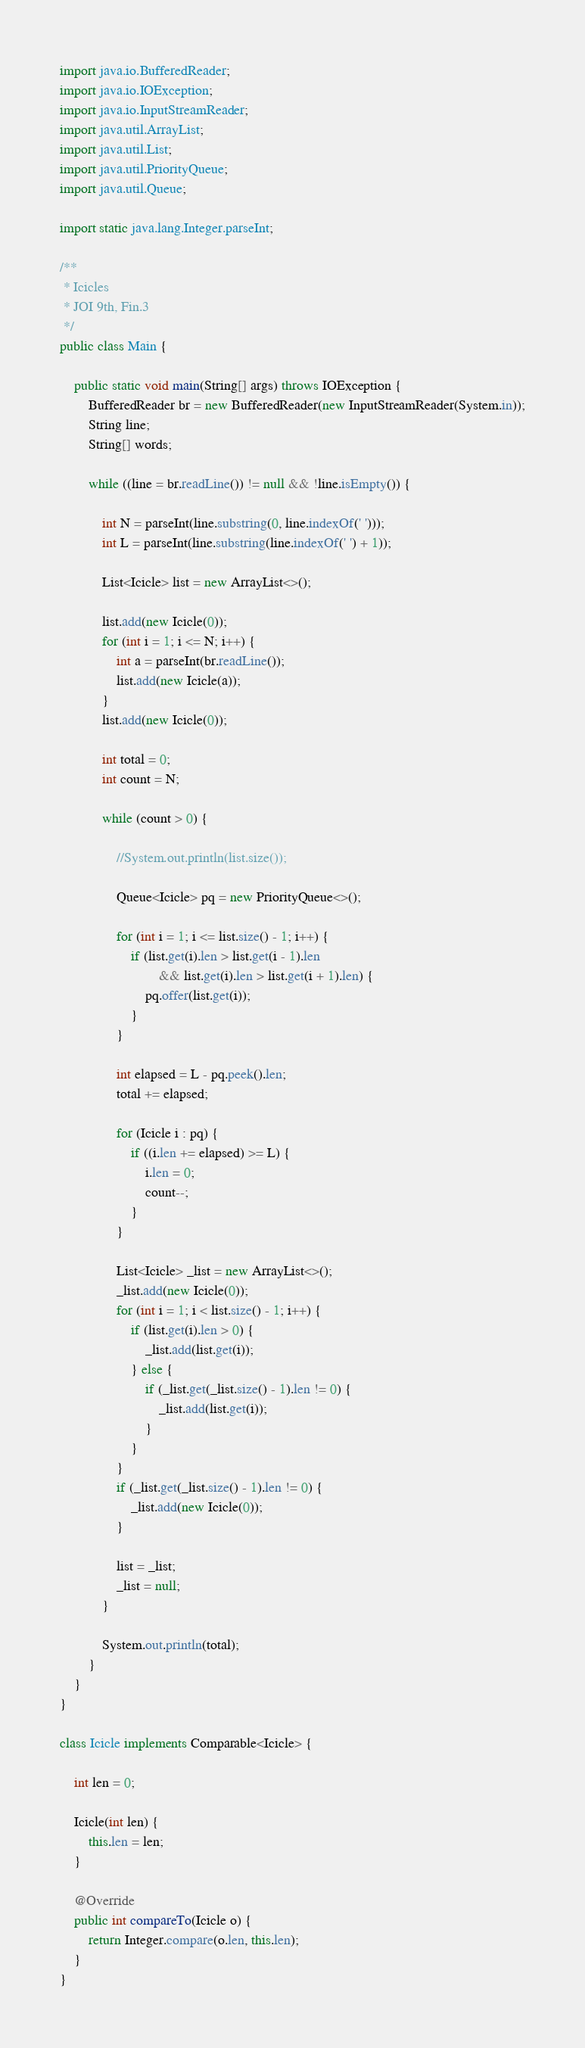Convert code to text. <code><loc_0><loc_0><loc_500><loc_500><_Java_>import java.io.BufferedReader;
import java.io.IOException;
import java.io.InputStreamReader;
import java.util.ArrayList;
import java.util.List;
import java.util.PriorityQueue;
import java.util.Queue;

import static java.lang.Integer.parseInt;

/**
 * Icicles
 * JOI 9th, Fin.3
 */
public class Main {

	public static void main(String[] args) throws IOException {
		BufferedReader br = new BufferedReader(new InputStreamReader(System.in));
		String line;
		String[] words;

		while ((line = br.readLine()) != null && !line.isEmpty()) {

			int N = parseInt(line.substring(0, line.indexOf(' ')));
			int L = parseInt(line.substring(line.indexOf(' ') + 1));

			List<Icicle> list = new ArrayList<>();

			list.add(new Icicle(0));
			for (int i = 1; i <= N; i++) {
				int a = parseInt(br.readLine());
				list.add(new Icicle(a));
			}
			list.add(new Icicle(0));

			int total = 0;
			int count = N;

			while (count > 0) {

				//System.out.println(list.size());

				Queue<Icicle> pq = new PriorityQueue<>();

				for (int i = 1; i <= list.size() - 1; i++) {
					if (list.get(i).len > list.get(i - 1).len
							&& list.get(i).len > list.get(i + 1).len) {
						pq.offer(list.get(i));
					}
				}

				int elapsed = L - pq.peek().len;
				total += elapsed;

				for (Icicle i : pq) {
					if ((i.len += elapsed) >= L) {
						i.len = 0;
						count--;
					}
				}

				List<Icicle> _list = new ArrayList<>();
				_list.add(new Icicle(0));
				for (int i = 1; i < list.size() - 1; i++) {
					if (list.get(i).len > 0) {
						_list.add(list.get(i));
					} else {
						if (_list.get(_list.size() - 1).len != 0) {
							_list.add(list.get(i));
						}
					}
				}
				if (_list.get(_list.size() - 1).len != 0) {
					_list.add(new Icicle(0));
				}

				list = _list;
				_list = null;
			}

			System.out.println(total);
		}
	}
}

class Icicle implements Comparable<Icicle> {

	int len = 0;

	Icicle(int len) {
		this.len = len;
	}

	@Override
	public int compareTo(Icicle o) {
		return Integer.compare(o.len, this.len);
	}
}</code> 